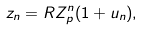Convert formula to latex. <formula><loc_0><loc_0><loc_500><loc_500>z _ { n } = R Z _ { p } ^ { n } ( 1 + u _ { n } ) ,</formula> 